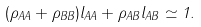Convert formula to latex. <formula><loc_0><loc_0><loc_500><loc_500>( \rho _ { A A } + \rho _ { B B } ) l _ { A A } + \rho _ { A B } l _ { A B } \simeq 1 .</formula> 